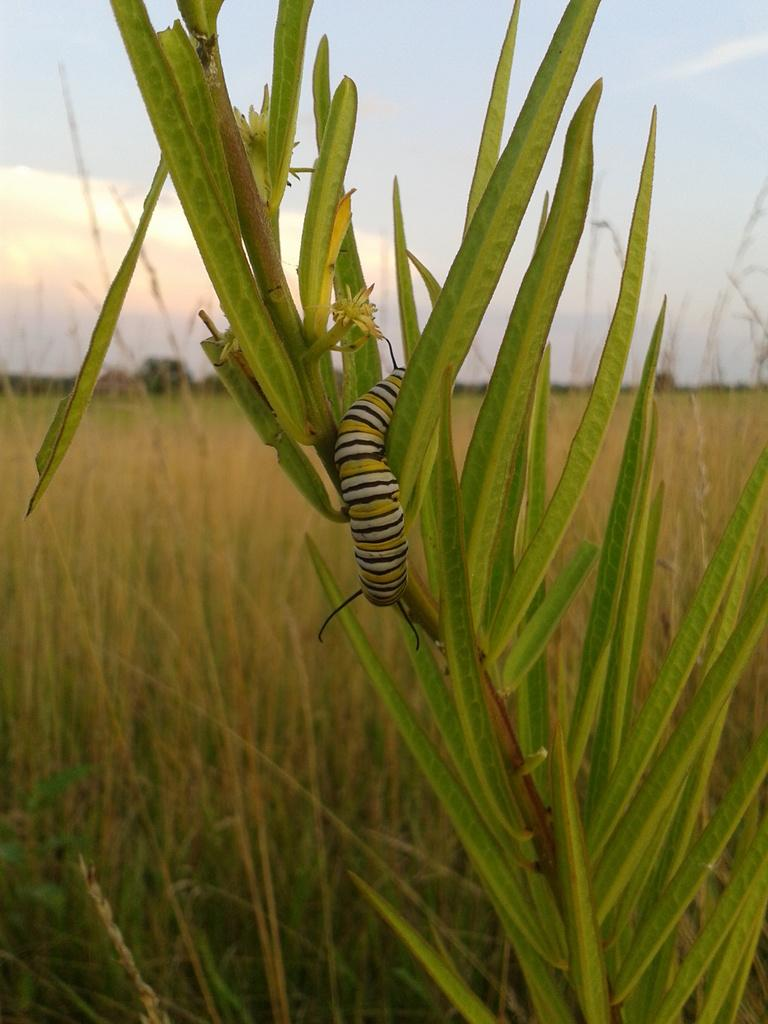What is present on the plant in the image? There is an insect on a plant in the image. What type of vegetation can be seen in the background of the image? There is grass visible in the background of the image. What part of the natural environment is visible in the image? The sky is visible in the background of the image. How many connections can be seen between the insect and the plant in the image? There is no indication of any connections between the insect and the plant in the image. 